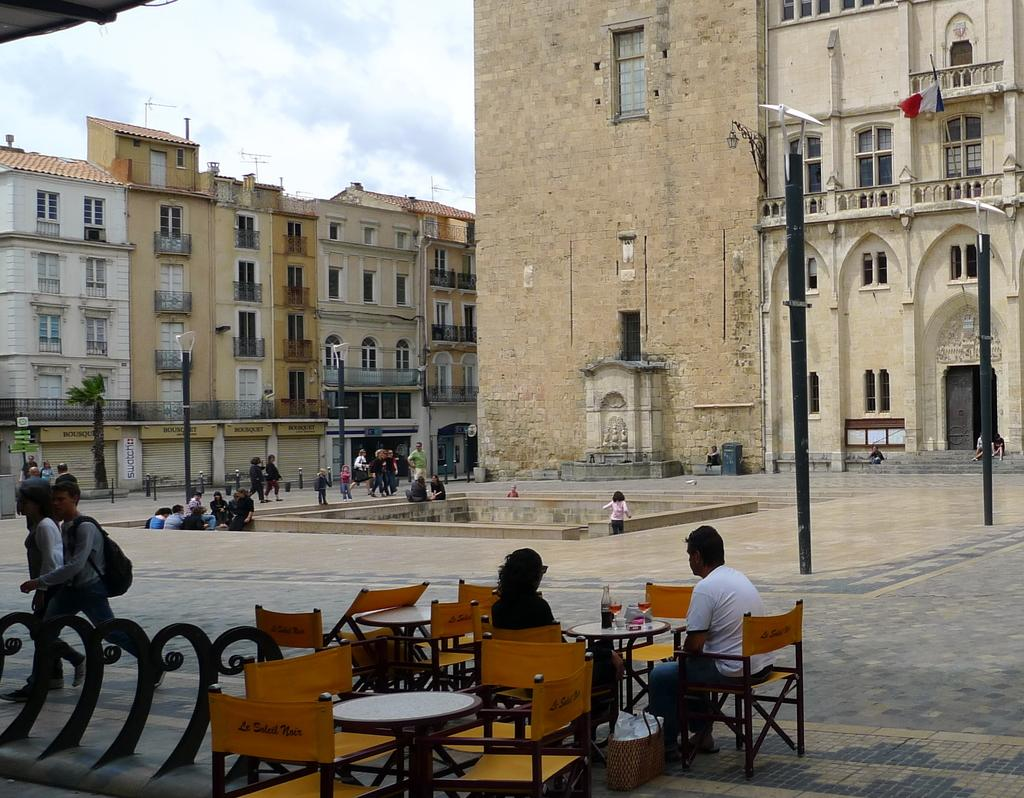What can be seen in the background of the image? There is a sky in the image. What structures are present in the image? There are buildings in the image. What are the people in the image doing? There are people standing and walking on the road in the image. What type of furniture is visible in the image? There are chairs and tables in the image. What type of machine can be seen operating on the road in the image? There is no machine operating on the road in the image. How many trains are visible in the image? There are no trains present in the image. 